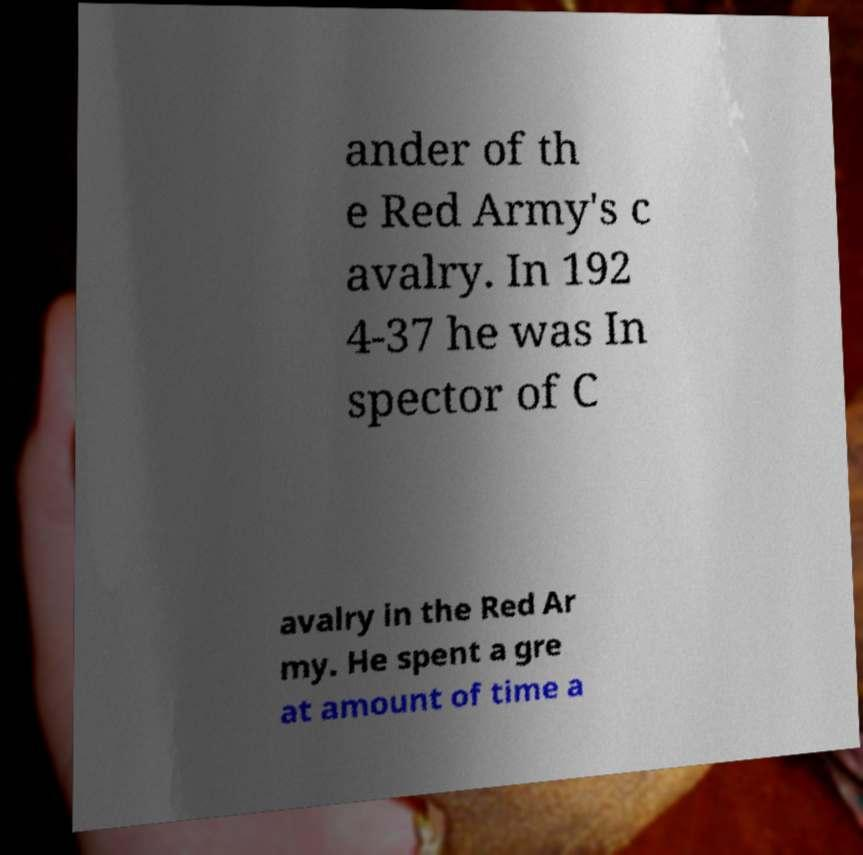Please read and relay the text visible in this image. What does it say? ander of th e Red Army's c avalry. In 192 4-37 he was In spector of C avalry in the Red Ar my. He spent a gre at amount of time a 